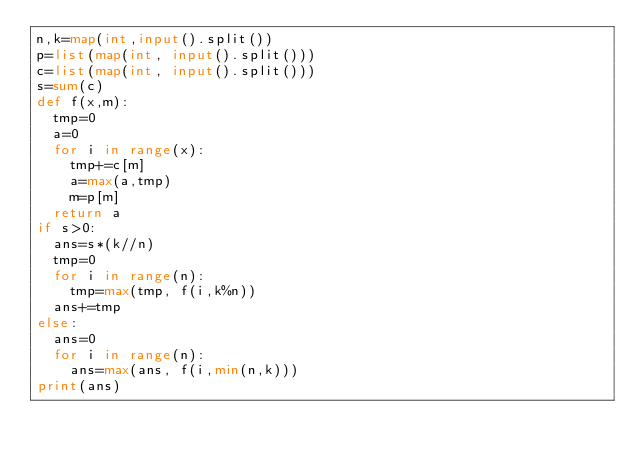<code> <loc_0><loc_0><loc_500><loc_500><_Python_>n,k=map(int,input().split())
p=list(map(int, input().split()))
c=list(map(int, input().split()))
s=sum(c)
def f(x,m):
  tmp=0
  a=0
  for i in range(x):
    tmp+=c[m]
    a=max(a,tmp)
    m=p[m]
  return a
if s>0:
  ans=s*(k//n)
  tmp=0
  for i in range(n):
    tmp=max(tmp, f(i,k%n))
  ans+=tmp
else:
  ans=0
  for i in range(n):
    ans=max(ans, f(i,min(n,k)))
print(ans)</code> 